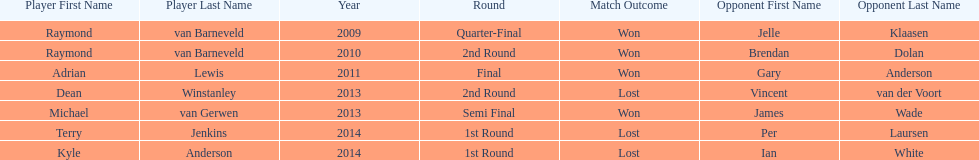Who are the only players listed that played in 2011? Adrian Lewis. 